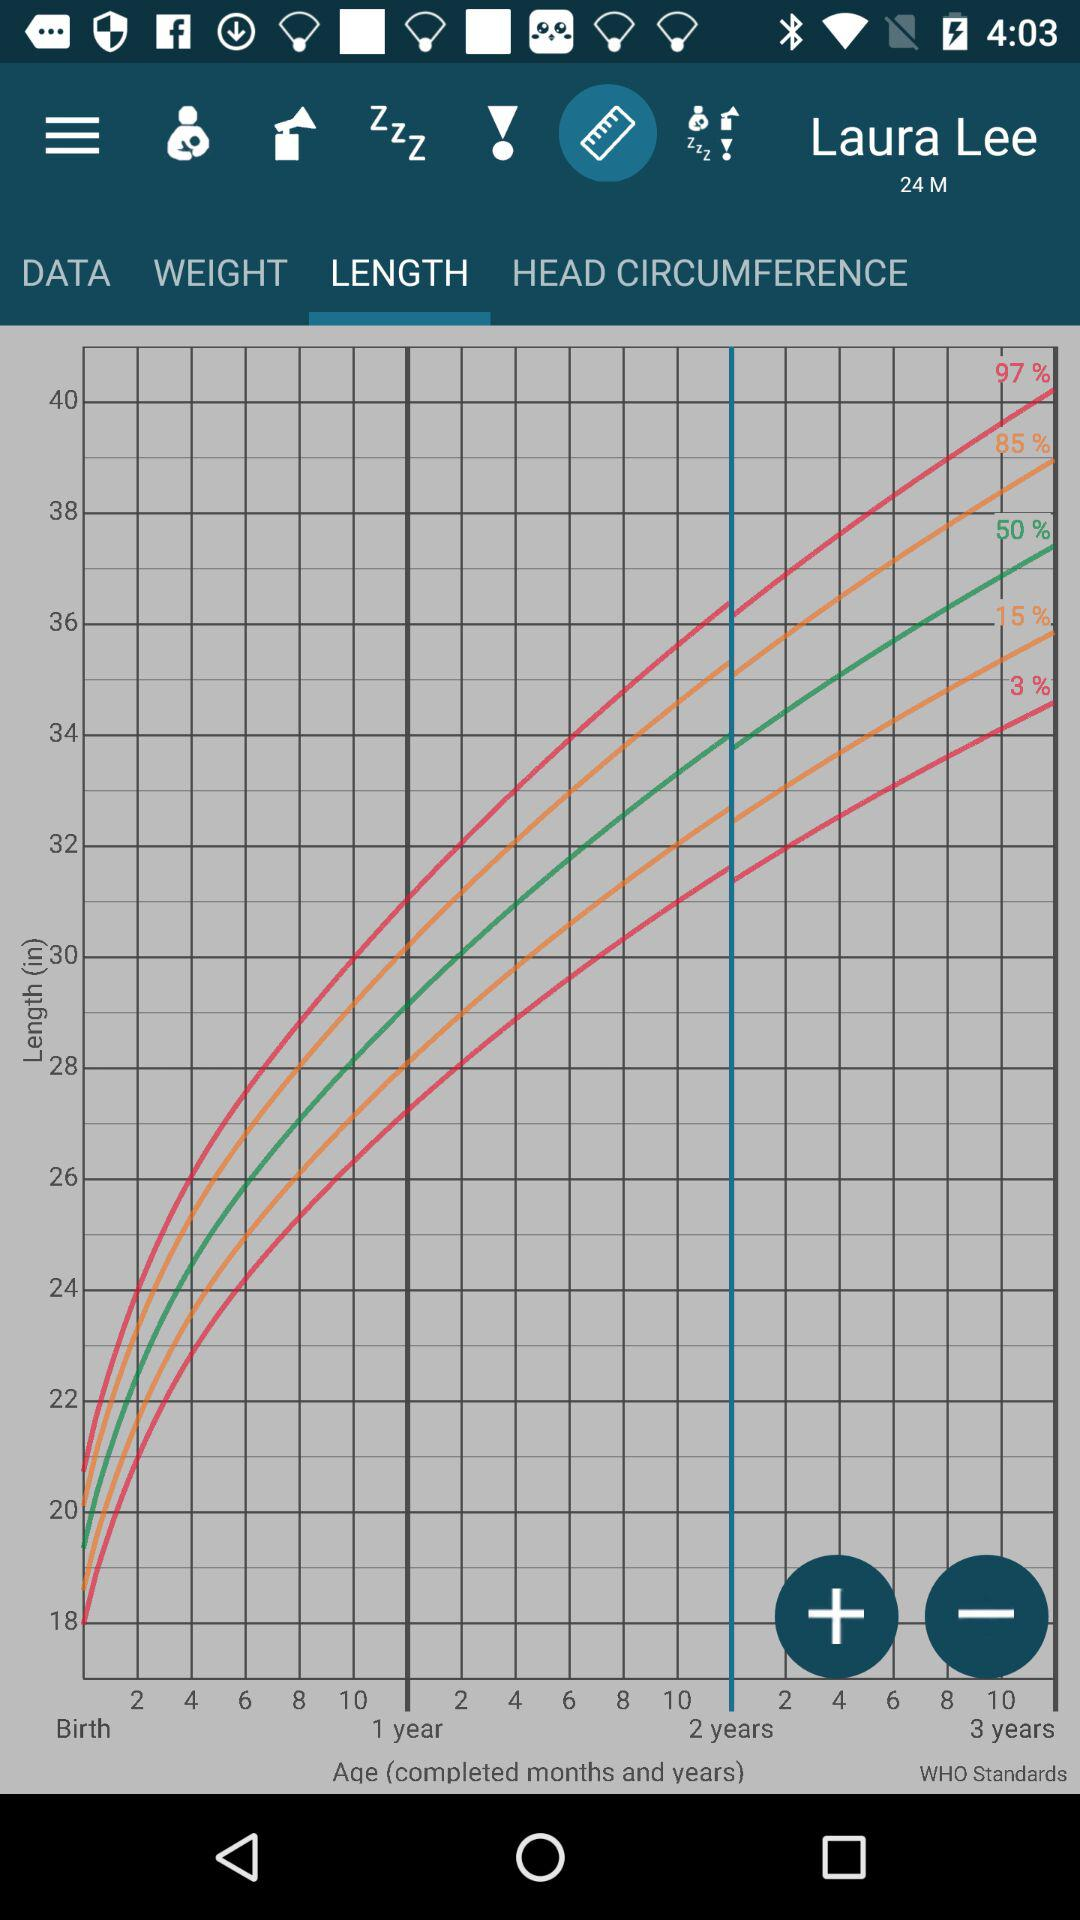Which tab is selected? The selected tab is "LENGTH". 